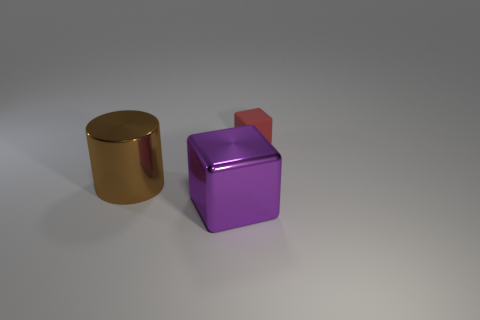How many objects are purple things or large objects that are in front of the large metallic cylinder?
Give a very brief answer. 1. What is the thing that is to the right of the brown metallic thing and to the left of the tiny red object made of?
Provide a succinct answer. Metal. What is the object behind the brown metallic cylinder made of?
Ensure brevity in your answer.  Rubber. What color is the thing that is made of the same material as the large purple cube?
Make the answer very short. Brown. There is a red thing; is its shape the same as the metallic thing that is behind the large purple object?
Your answer should be very brief. No. There is a big purple object; are there any objects on the right side of it?
Make the answer very short. Yes. There is a purple shiny object; is its size the same as the thing to the left of the purple metal block?
Provide a succinct answer. Yes. Is there another big object that has the same shape as the brown thing?
Your answer should be very brief. No. What shape is the object that is to the right of the large brown cylinder and on the left side of the small red rubber block?
Ensure brevity in your answer.  Cube. How many red blocks have the same material as the large brown object?
Make the answer very short. 0. 